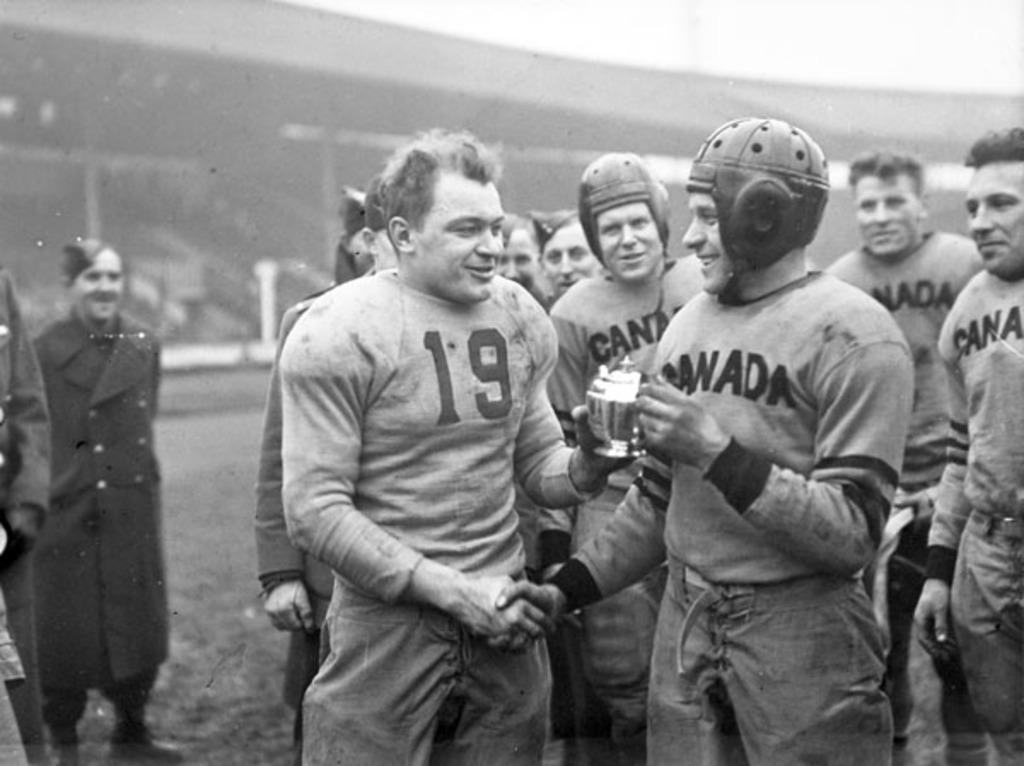Can you describe this image briefly? This is a black and white picture, in this image we can see a few people standing, among them some are wearing the helmets and in the background, it looks like a building. 